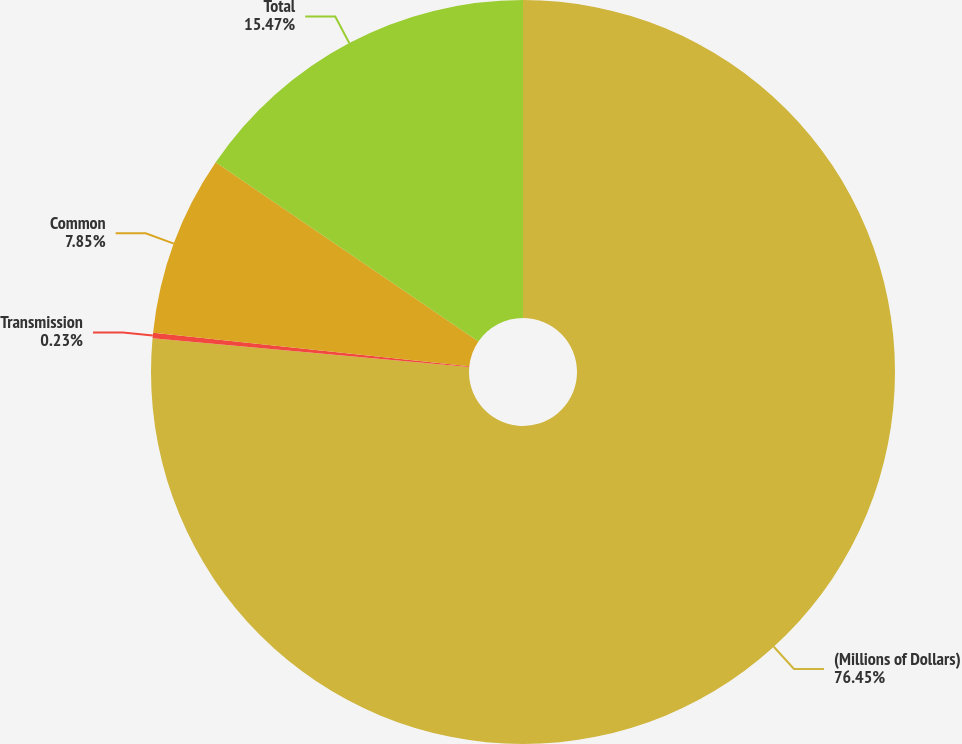Convert chart to OTSL. <chart><loc_0><loc_0><loc_500><loc_500><pie_chart><fcel>(Millions of Dollars)<fcel>Transmission<fcel>Common<fcel>Total<nl><fcel>76.45%<fcel>0.23%<fcel>7.85%<fcel>15.47%<nl></chart> 